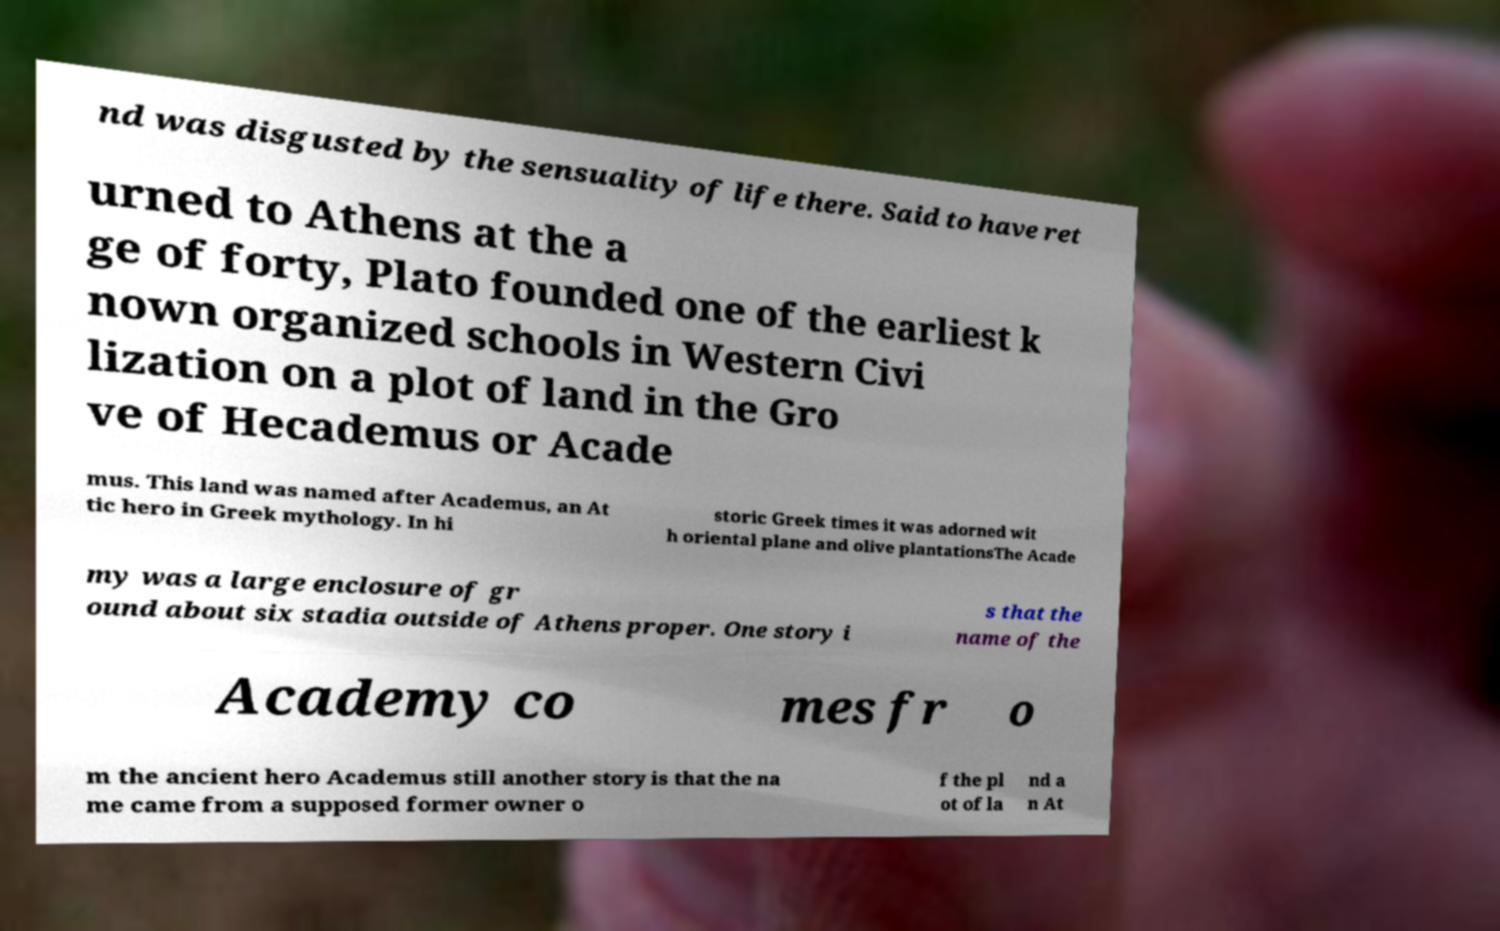Can you accurately transcribe the text from the provided image for me? nd was disgusted by the sensuality of life there. Said to have ret urned to Athens at the a ge of forty, Plato founded one of the earliest k nown organized schools in Western Civi lization on a plot of land in the Gro ve of Hecademus or Acade mus. This land was named after Academus, an At tic hero in Greek mythology. In hi storic Greek times it was adorned wit h oriental plane and olive plantationsThe Acade my was a large enclosure of gr ound about six stadia outside of Athens proper. One story i s that the name of the Academy co mes fr o m the ancient hero Academus still another story is that the na me came from a supposed former owner o f the pl ot of la nd a n At 